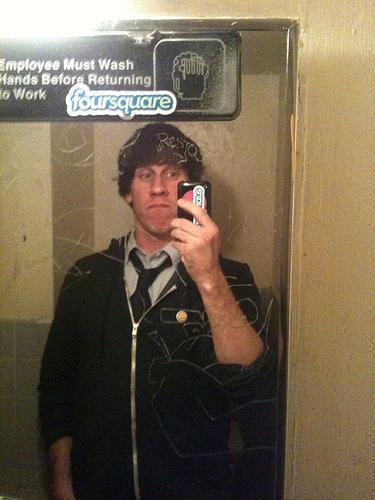How many foursquare stickers are in this photo?
Give a very brief answer. 2. 